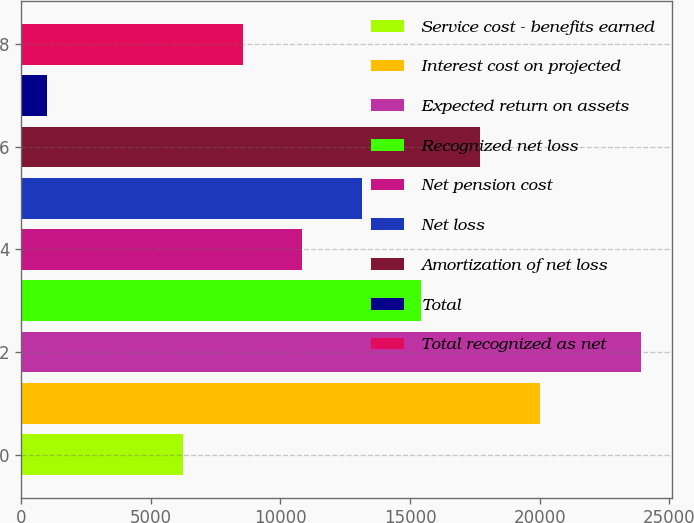Convert chart. <chart><loc_0><loc_0><loc_500><loc_500><bar_chart><fcel>Service cost - benefits earned<fcel>Interest cost on projected<fcel>Expected return on assets<fcel>Recognized net loss<fcel>Net pension cost<fcel>Net loss<fcel>Amortization of net loss<fcel>Total<fcel>Total recognized as net<nl><fcel>6250<fcel>20006.2<fcel>23923<fcel>15420.8<fcel>10835.4<fcel>13128.1<fcel>17713.5<fcel>996<fcel>8542.7<nl></chart> 